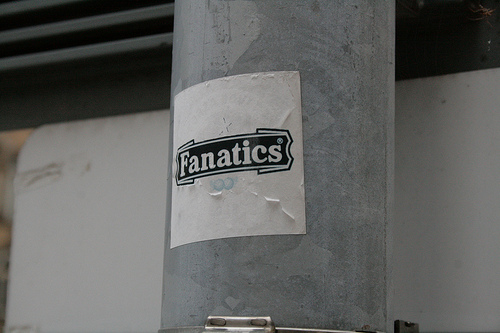<image>
Is there a fanatics on the pole? Yes. Looking at the image, I can see the fanatics is positioned on top of the pole, with the pole providing support. Where is the fanatics in relation to the pole? Is it next to the pole? No. The fanatics is not positioned next to the pole. They are located in different areas of the scene. 